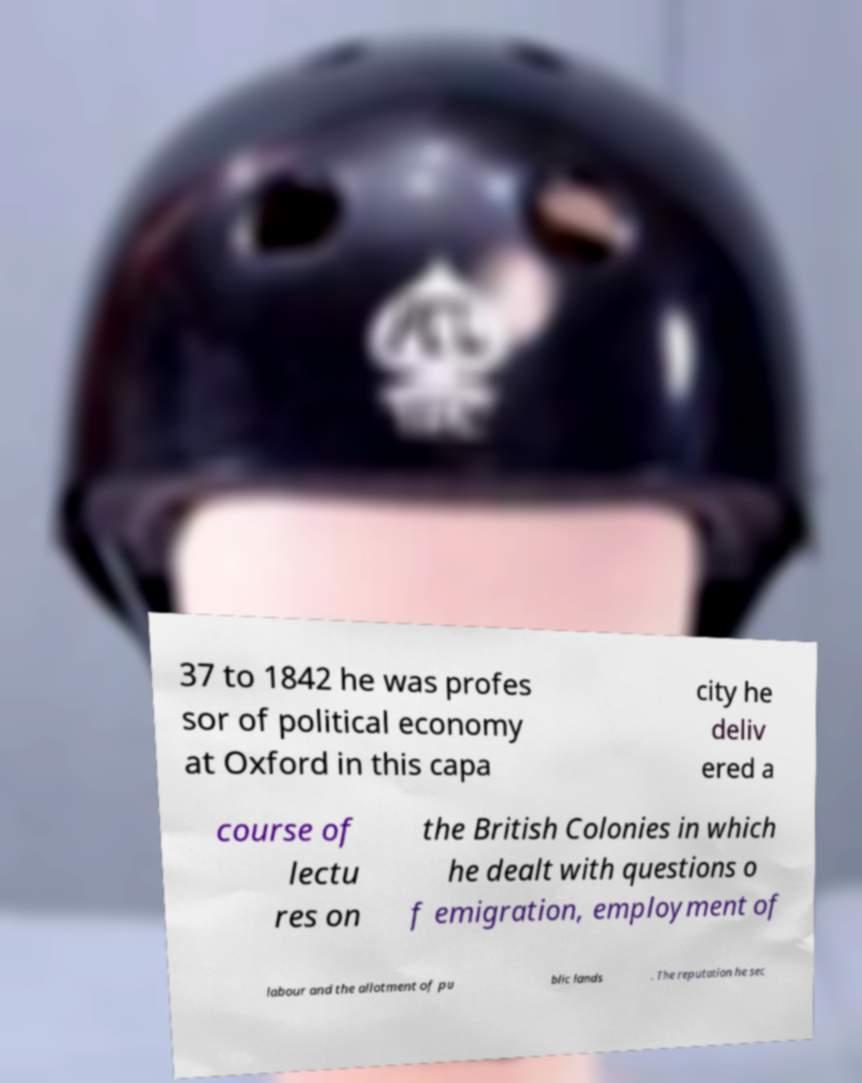What messages or text are displayed in this image? I need them in a readable, typed format. 37 to 1842 he was profes sor of political economy at Oxford in this capa city he deliv ered a course of lectu res on the British Colonies in which he dealt with questions o f emigration, employment of labour and the allotment of pu blic lands . The reputation he sec 